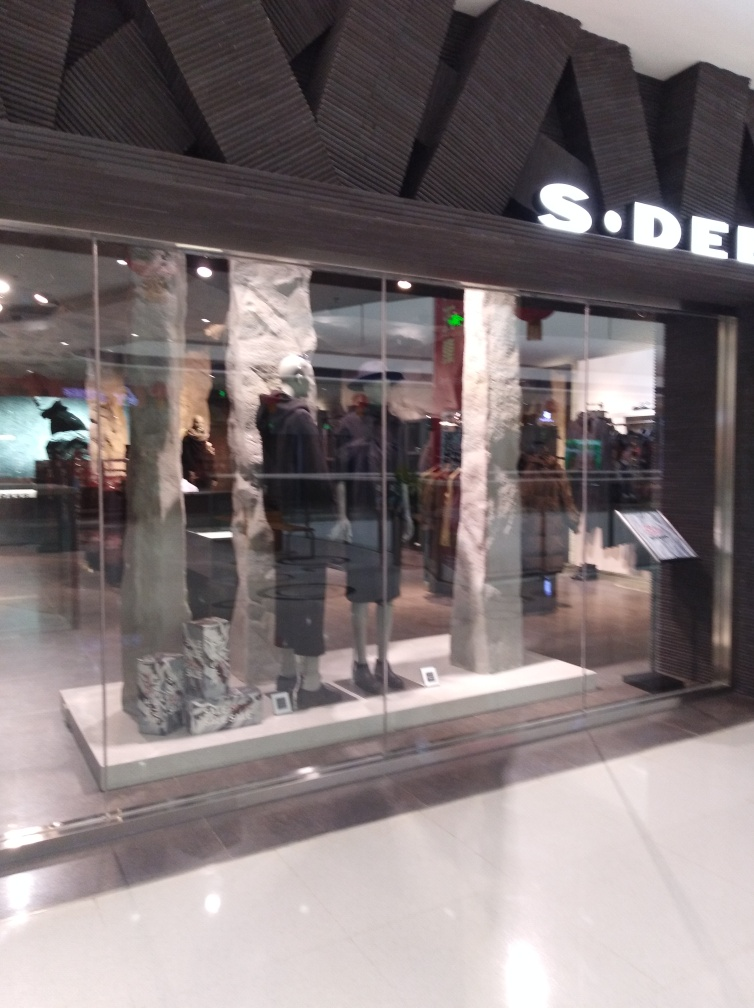What is the overall ambiance of the store's design? The store has a modern and chic ambiance, with a sleek storefront design incorporating natural textures and materials that create an upscale shopping experience. Does the design seem to target a specific type of shopper? Yes, the store's minimalist and stylish design suggests it is targeting fashion-conscious customers looking for high-end apparel. 